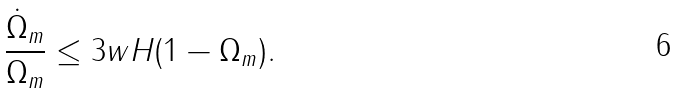<formula> <loc_0><loc_0><loc_500><loc_500>\frac { \dot { \Omega } _ { m } } { \Omega _ { m } } \leq 3 w H ( 1 - \Omega _ { m } ) .</formula> 